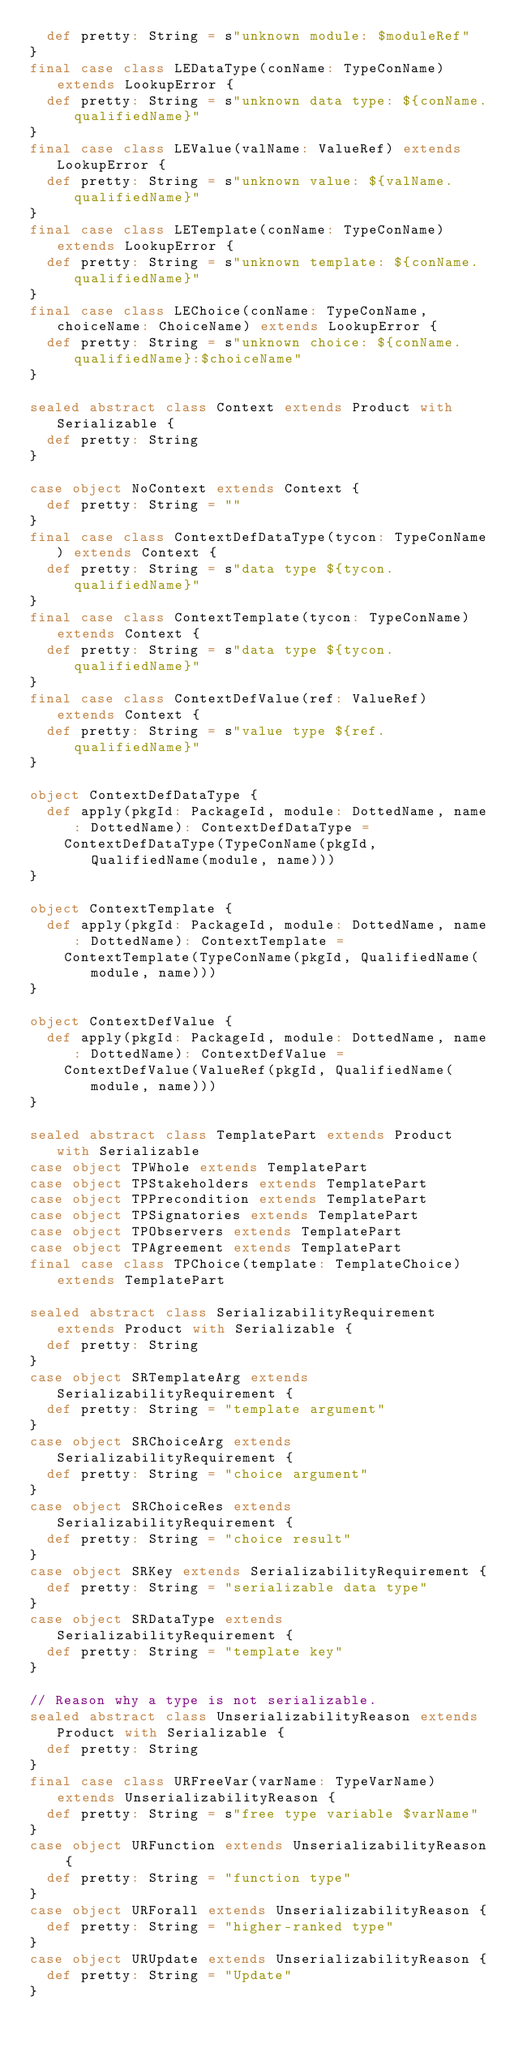Convert code to text. <code><loc_0><loc_0><loc_500><loc_500><_Scala_>  def pretty: String = s"unknown module: $moduleRef"
}
final case class LEDataType(conName: TypeConName) extends LookupError {
  def pretty: String = s"unknown data type: ${conName.qualifiedName}"
}
final case class LEValue(valName: ValueRef) extends LookupError {
  def pretty: String = s"unknown value: ${valName.qualifiedName}"
}
final case class LETemplate(conName: TypeConName) extends LookupError {
  def pretty: String = s"unknown template: ${conName.qualifiedName}"
}
final case class LEChoice(conName: TypeConName, choiceName: ChoiceName) extends LookupError {
  def pretty: String = s"unknown choice: ${conName.qualifiedName}:$choiceName"
}

sealed abstract class Context extends Product with Serializable {
  def pretty: String
}

case object NoContext extends Context {
  def pretty: String = ""
}
final case class ContextDefDataType(tycon: TypeConName) extends Context {
  def pretty: String = s"data type ${tycon.qualifiedName}"
}
final case class ContextTemplate(tycon: TypeConName) extends Context {
  def pretty: String = s"data type ${tycon.qualifiedName}"
}
final case class ContextDefValue(ref: ValueRef) extends Context {
  def pretty: String = s"value type ${ref.qualifiedName}"
}

object ContextDefDataType {
  def apply(pkgId: PackageId, module: DottedName, name: DottedName): ContextDefDataType =
    ContextDefDataType(TypeConName(pkgId, QualifiedName(module, name)))
}

object ContextTemplate {
  def apply(pkgId: PackageId, module: DottedName, name: DottedName): ContextTemplate =
    ContextTemplate(TypeConName(pkgId, QualifiedName(module, name)))
}

object ContextDefValue {
  def apply(pkgId: PackageId, module: DottedName, name: DottedName): ContextDefValue =
    ContextDefValue(ValueRef(pkgId, QualifiedName(module, name)))
}

sealed abstract class TemplatePart extends Product with Serializable
case object TPWhole extends TemplatePart
case object TPStakeholders extends TemplatePart
case object TPPrecondition extends TemplatePart
case object TPSignatories extends TemplatePart
case object TPObservers extends TemplatePart
case object TPAgreement extends TemplatePart
final case class TPChoice(template: TemplateChoice) extends TemplatePart

sealed abstract class SerializabilityRequirement extends Product with Serializable {
  def pretty: String
}
case object SRTemplateArg extends SerializabilityRequirement {
  def pretty: String = "template argument"
}
case object SRChoiceArg extends SerializabilityRequirement {
  def pretty: String = "choice argument"
}
case object SRChoiceRes extends SerializabilityRequirement {
  def pretty: String = "choice result"
}
case object SRKey extends SerializabilityRequirement {
  def pretty: String = "serializable data type"
}
case object SRDataType extends SerializabilityRequirement {
  def pretty: String = "template key"
}

// Reason why a type is not serializable.
sealed abstract class UnserializabilityReason extends Product with Serializable {
  def pretty: String
}
final case class URFreeVar(varName: TypeVarName) extends UnserializabilityReason {
  def pretty: String = s"free type variable $varName"
}
case object URFunction extends UnserializabilityReason {
  def pretty: String = "function type"
}
case object URForall extends UnserializabilityReason {
  def pretty: String = "higher-ranked type"
}
case object URUpdate extends UnserializabilityReason {
  def pretty: String = "Update"
}</code> 